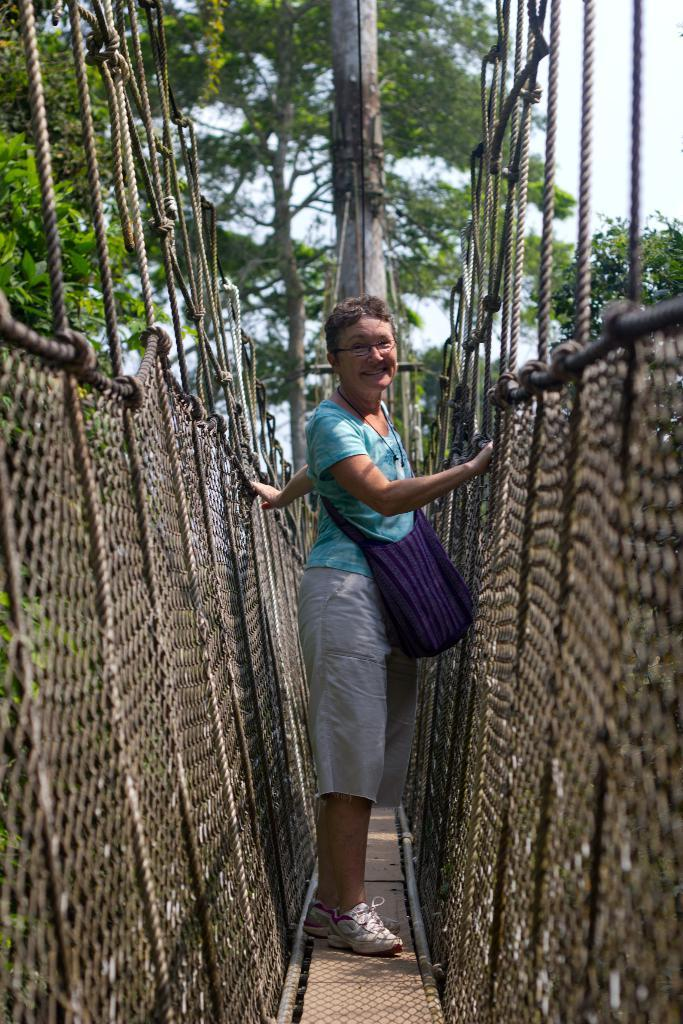Who is present in the image? There is a woman in the image. What is the woman doing in the image? The woman is standing on a rope bridge. What is the woman's expression in the image? The woman is smiling. What can be seen behind the woman in the image? There is a pole behind the woman. What is visible in the background of the image? Trees are visible in the background. What is the woman's aunt doing at her birth in the image? There is no information about the woman's aunt or her birth in the image. 